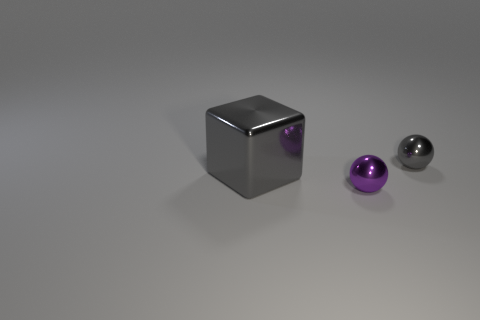Is there anything else that is the same shape as the large gray metal object?
Your answer should be compact. No. There is a object in front of the gray shiny thing in front of the tiny gray object; what is its material?
Your response must be concise. Metal. Is the number of big metal objects right of the purple object greater than the number of small yellow metallic cubes?
Keep it short and to the point. No. How many other things are there of the same color as the large thing?
Offer a very short reply. 1. The gray thing that is the same size as the purple sphere is what shape?
Keep it short and to the point. Sphere. What number of small spheres are to the left of the metal sphere that is behind the tiny metal sphere in front of the large gray object?
Your answer should be very brief. 1. What number of metal things are tiny balls or tiny purple balls?
Your answer should be very brief. 2. There is a metal object that is both to the left of the gray sphere and on the right side of the block; what is its color?
Ensure brevity in your answer.  Purple. There is a gray object that is right of the purple object; is it the same size as the small purple shiny ball?
Keep it short and to the point. Yes. What number of things are either metal things that are behind the large gray thing or brown shiny cylinders?
Make the answer very short. 1. 